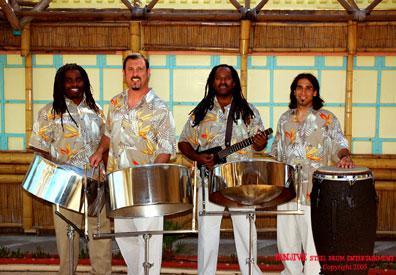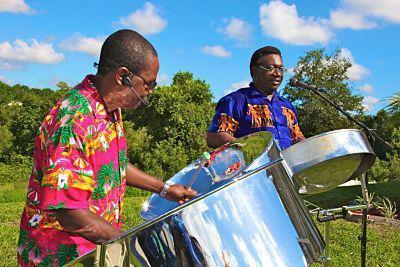The first image is the image on the left, the second image is the image on the right. Given the left and right images, does the statement "Some musicians are wearing hats." hold true? Answer yes or no. No. The first image is the image on the left, the second image is the image on the right. For the images displayed, is the sentence "Each image includes at least three men standing behind drums, and at least one man in each image is wearing a hawaiian shirt." factually correct? Answer yes or no. No. 